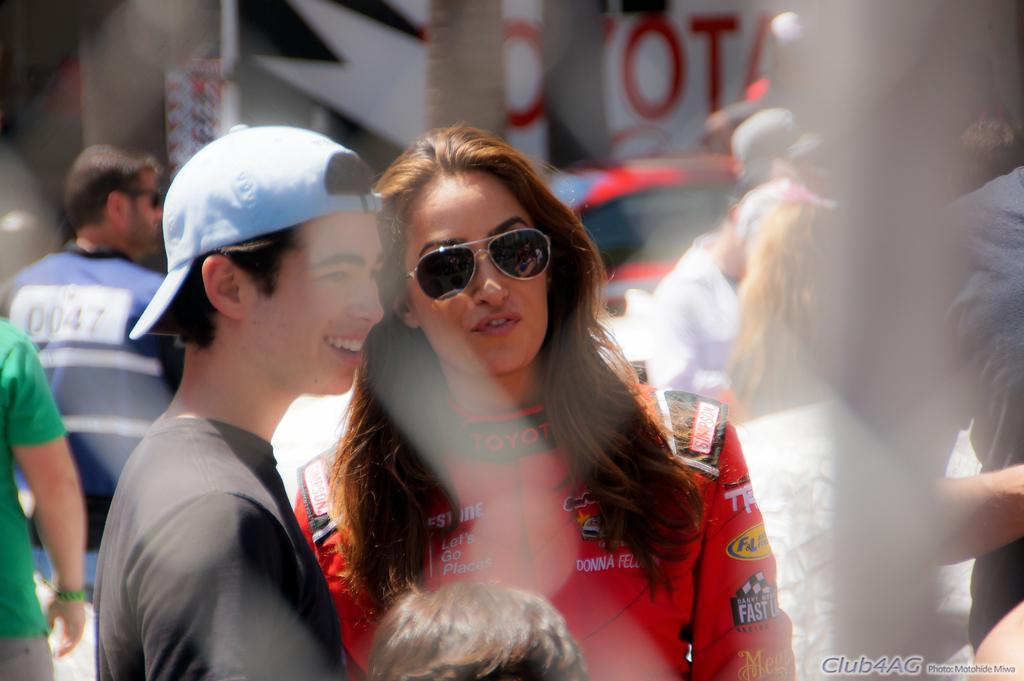What can be seen in the foreground of the image? There are people standing in the image. How would you describe the background of the image? The background of the image is blurry. What type of cream is being used by the group in the image? There is no cream or group present in the image; it only shows people standing. What flag is being waved by the people in the image? There is no flag present in the image; it only shows people standing. 